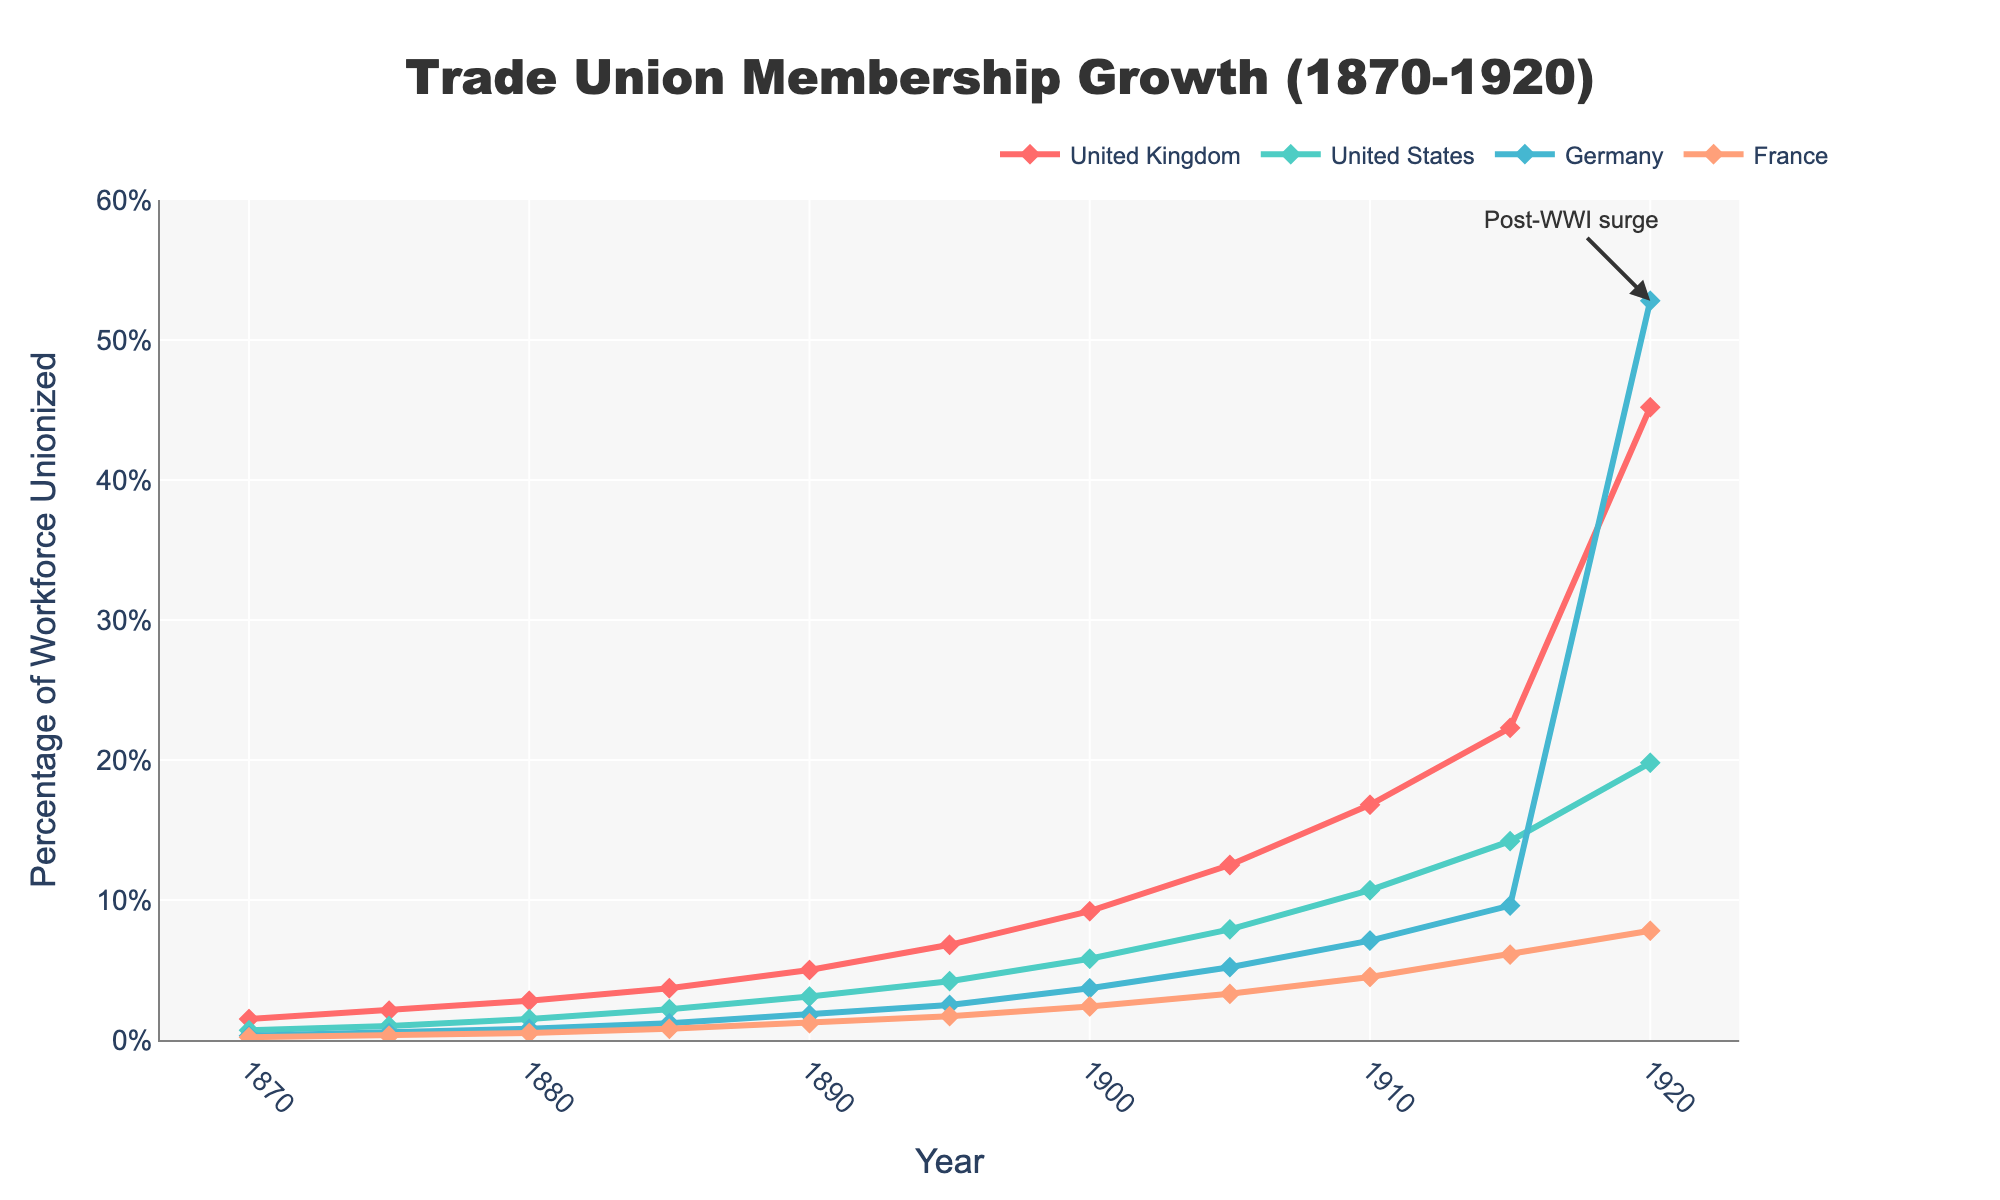What is the highest percentage of workforce unionized in Germany between 1870 and 1920? The highest value on the Germany line in the chart is 52.8% in 1920
Answer: 52.8% Which country had the highest percentage of workforce unionized in 1920? In 1920, the data points show that Germany had the highest percentage at 52.8%
Answer: Germany Compare the growth of trade union membership in the United Kingdom and the United States from 1870 to 1920. By the end of the period in 1920, the United Kingdom grew from 1.5% to 45.2%, while the United States grew from 0.7% to 19.8%
Answer: The United Kingdom had greater growth What was the difference in trade union membership percentage between Germany and France in 1920? Germany had 52.8% and France had 7.8%. The difference is 52.8% - 7.8%
Answer: 45% How did trade union membership in France compare to the United States in 1900? In 1900, France was at 2.4% while the United States was at 5.8%, indicating that the US had higher membership
Answer: The United States had higher membership What trends can you observe in the United Kingdom's trade union membership over the years? The line for the United Kingdom shows a consistently upward trend from 1.5% in 1870 to 45.2% in 1920, indicating steady growth
Answer: Steady growth Which country experienced a noticeable surge in trade union membership post-World War I? The annotation on the chart highlights that Germany saw a significant increase in 1920
Answer: Germany Compare the trade union memberships of Germany and the United Kingdom in 1915. In 1915, Germany is at 9.6% while the United Kingdom is at 22.3%. Thus, the UK had higher membership
Answer: The United Kingdom had higher membership What was the average trade union membership percentage in the United Kingdom between 1870 and 1920? Summing percentages from 1870 to 1920 (1.5+2.1+2.8+3.7+5.0+6.8+9.2+12.5+16.8+22.3+45.2) = 127.9, then dividing by 11
Answer: 11.63% Which country had the lowest starting point for trade union membership in 1870? In 1870, the values are UK: 1.5%, USA: 0.7%, Germany: 0.3%, France: 0.2%. France had the lowest starting point
Answer: France 